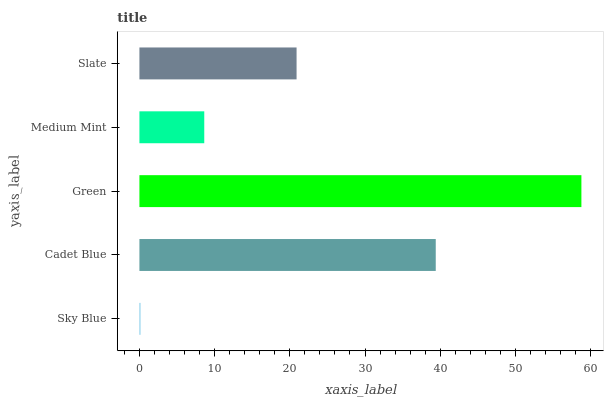Is Sky Blue the minimum?
Answer yes or no. Yes. Is Green the maximum?
Answer yes or no. Yes. Is Cadet Blue the minimum?
Answer yes or no. No. Is Cadet Blue the maximum?
Answer yes or no. No. Is Cadet Blue greater than Sky Blue?
Answer yes or no. Yes. Is Sky Blue less than Cadet Blue?
Answer yes or no. Yes. Is Sky Blue greater than Cadet Blue?
Answer yes or no. No. Is Cadet Blue less than Sky Blue?
Answer yes or no. No. Is Slate the high median?
Answer yes or no. Yes. Is Slate the low median?
Answer yes or no. Yes. Is Green the high median?
Answer yes or no. No. Is Medium Mint the low median?
Answer yes or no. No. 